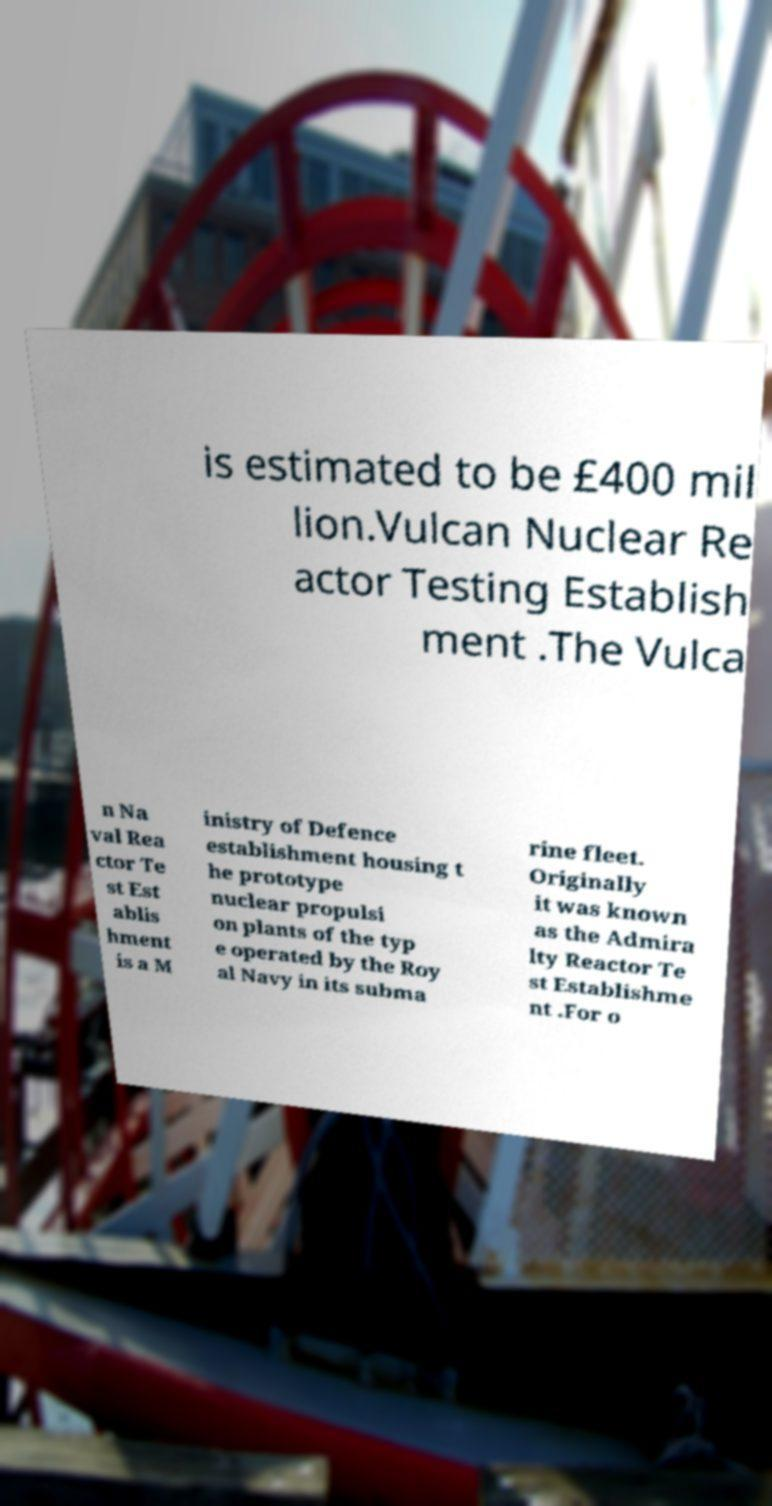I need the written content from this picture converted into text. Can you do that? is estimated to be £400 mil lion.Vulcan Nuclear Re actor Testing Establish ment .The Vulca n Na val Rea ctor Te st Est ablis hment is a M inistry of Defence establishment housing t he prototype nuclear propulsi on plants of the typ e operated by the Roy al Navy in its subma rine fleet. Originally it was known as the Admira lty Reactor Te st Establishme nt .For o 